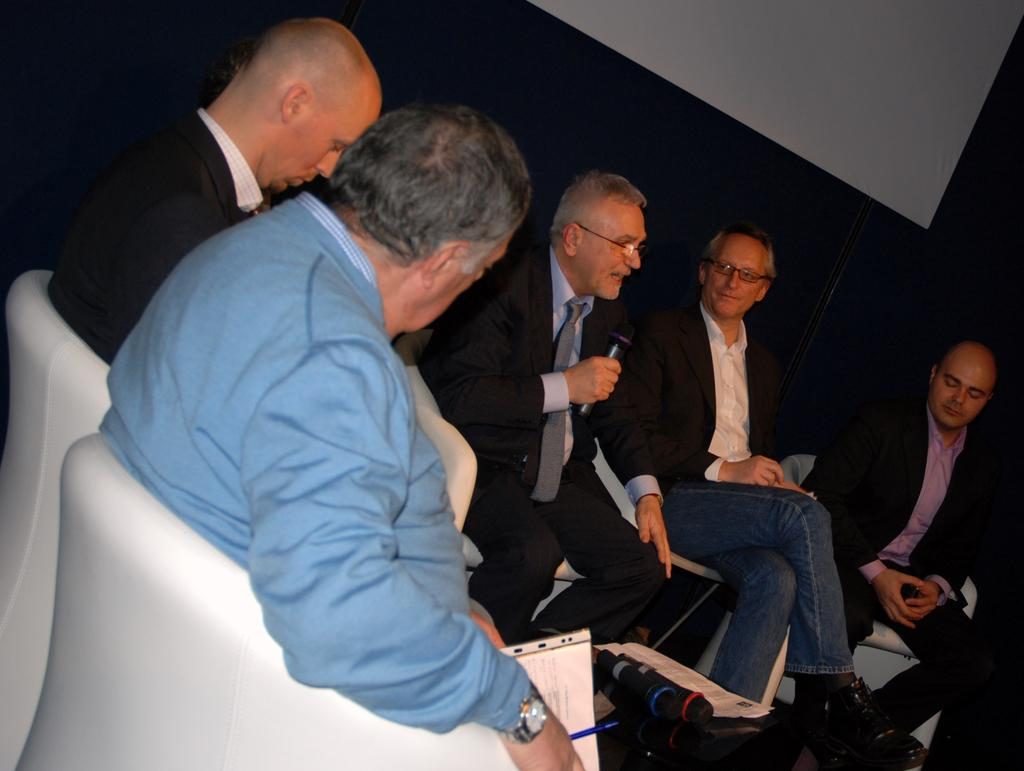How many people are in the image? There is a group of people in the image. What are the people doing in the image? The people are sitting on chairs. Who is holding a microphone in the image? A man is holding a microphone. What can be seen in the background of the image? There is a projector screen in the background. What type of arch can be seen in the image? There is no arch present in the image. What show is the man hosting with the microphone? The image does not provide information about a specific show or event that the man might be hosting. 